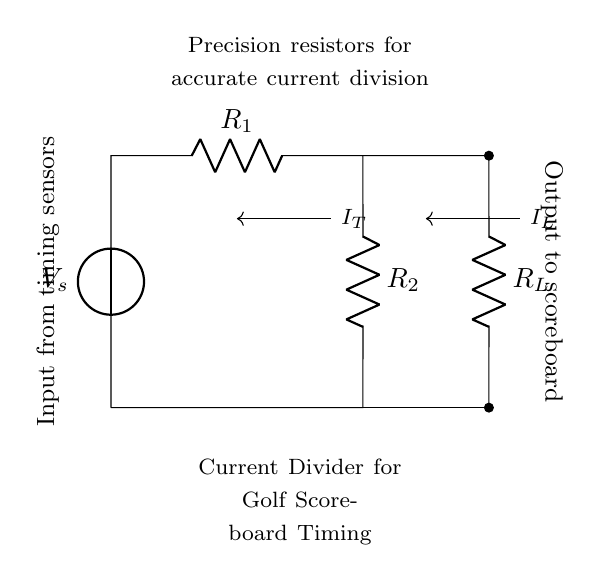What is the source voltage in this circuit? The source voltage, V_s, is indicated at the top left of the circuit diagram. It is the voltage supplied to the entire circuit.
Answer: V_s What are the resistor values used in the circuit? The circuit diagram includes two resistors labeled R_1 and R_2, but their specific values are not provided in the diagram. Typically, in current divider circuits, precise resistor values are essential for accurate current division.
Answer: R_1, R_2 How does current flow through the circuit? Current enters the circuit from the voltage source, splits at the junction between R_1 and R_2, and then flows through the load resistor R_L, returning to the source. This splitting is what allows the circuit to perform current division.
Answer: It splits at the junction What is the purpose of the load resistor in this circuit? The load resistor, R_L, is connected to the output of the current divider and receives the divided current. It converts the divided current into an output signal for the scoreboard, making it a critical component for the functionality of the circuit.
Answer: Generate output signal How is current divided between R_1 and R_2? The current division between R_1 and R_2 can be determined using the current divider rule. The current through each resistor is inversely proportional to its resistance value. This relationship is fundamental in ensuring the correct amount of current flows to the load.
Answer: Inversely proportional to resistance What is the significance of precision resistors in this circuit? Precision resistors ensure that the resistance values are tightly controlled and accurate, which is crucial for the reliable performance of the current divider. Any variation in these resistors can lead to incorrect current division, impacting the timing accuracy in the scoreboard.
Answer: Accurate current division 